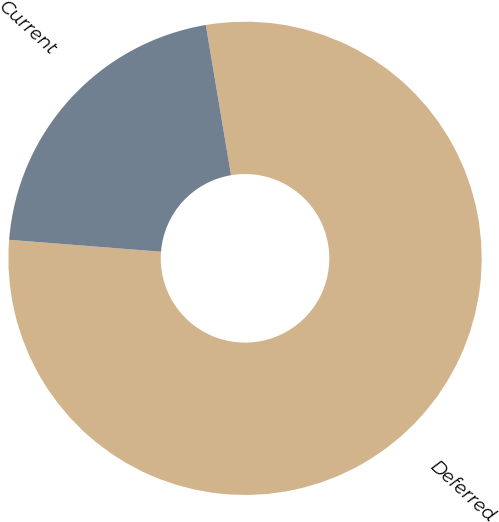<chart> <loc_0><loc_0><loc_500><loc_500><pie_chart><fcel>Deferred<fcel>Current<nl><fcel>78.9%<fcel>21.1%<nl></chart> 